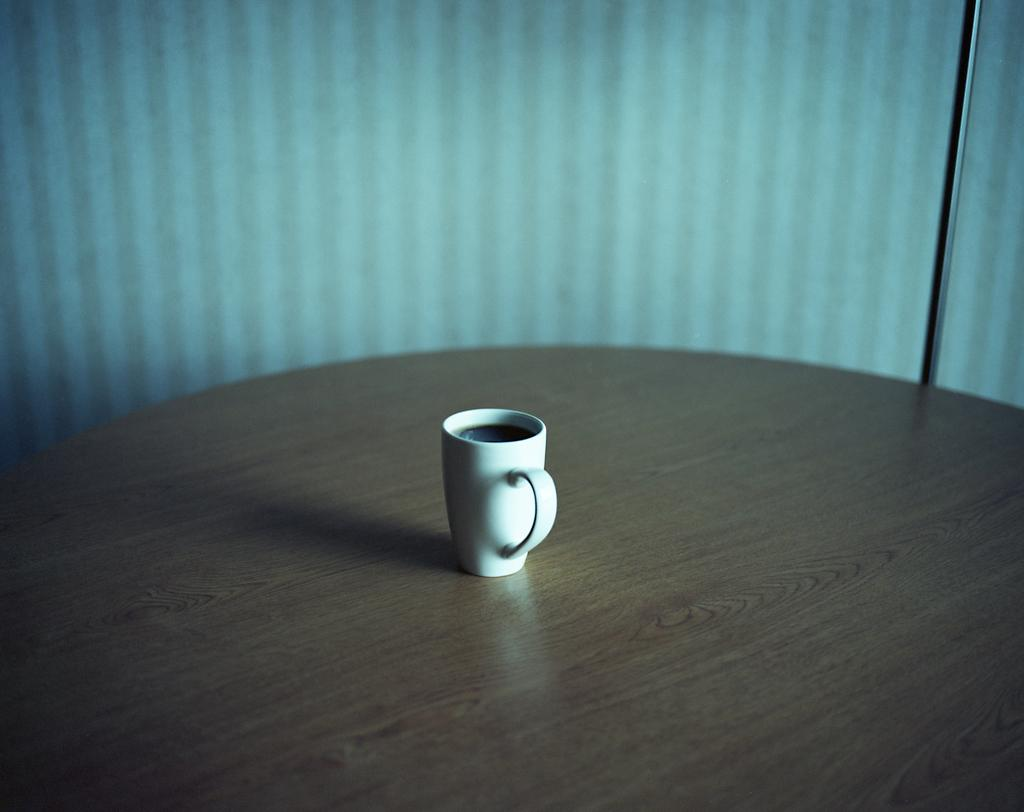What color is the cup that is visible in the image? The cup is white-colored in the image. Where is the cup located in the image? The cup is placed on a table in the image. How many cent of corn can be seen in the image? There is no corn present in the image, so it is not possible to determine the amount of corn. 